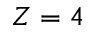<formula> <loc_0><loc_0><loc_500><loc_500>Z = 4</formula> 